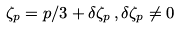Convert formula to latex. <formula><loc_0><loc_0><loc_500><loc_500>\zeta _ { p } = p / 3 + \delta \zeta _ { p } \, , \delta \zeta _ { p } \ne 0</formula> 